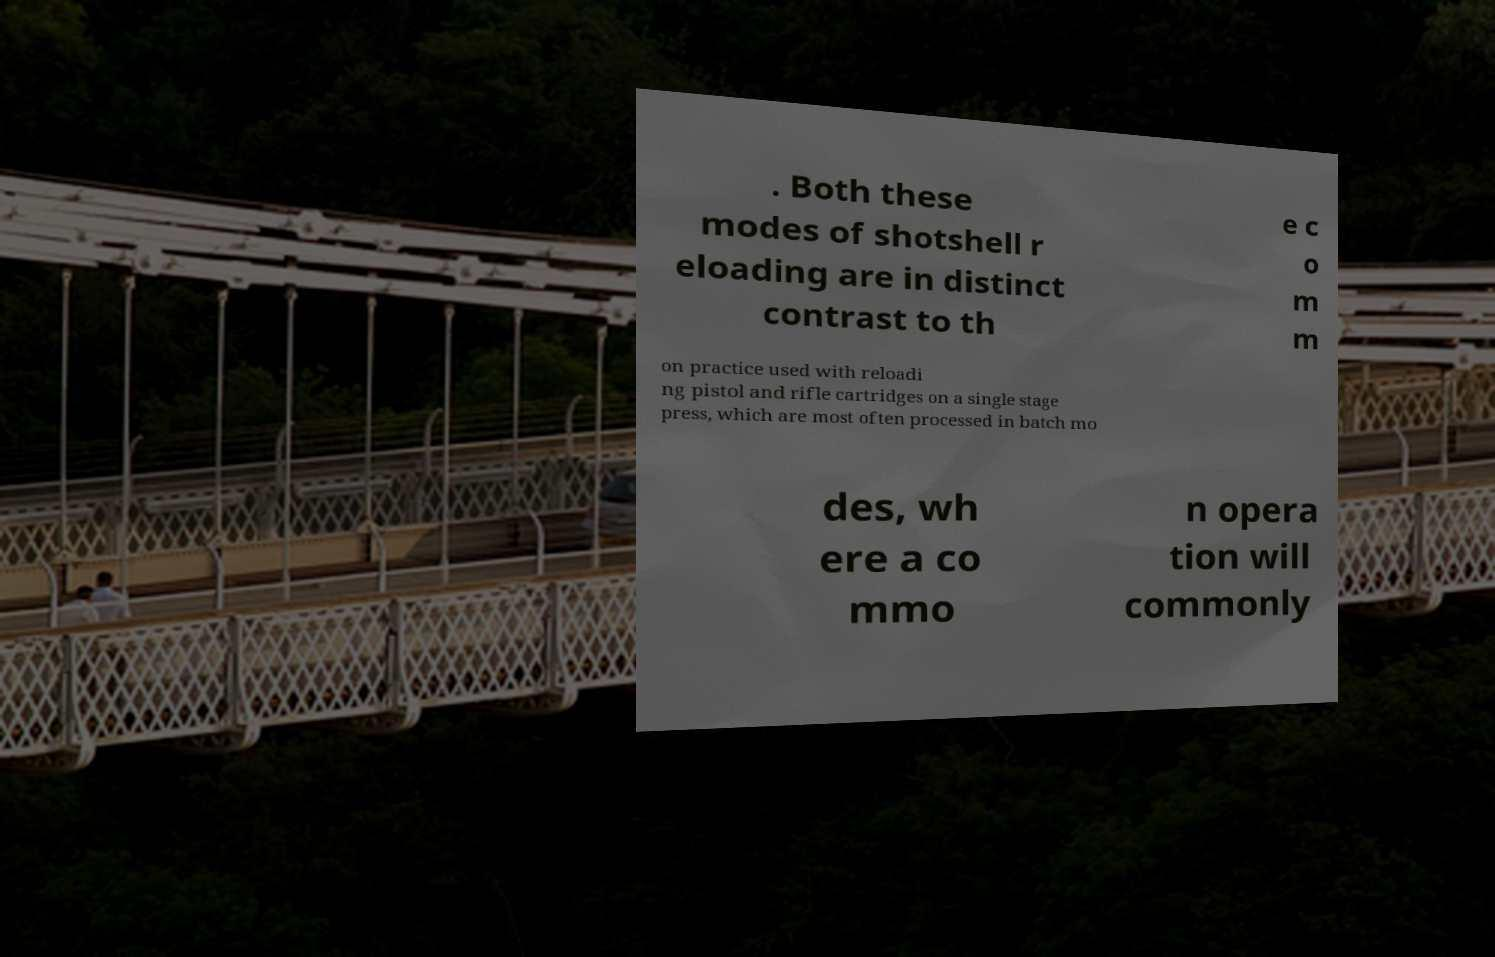For documentation purposes, I need the text within this image transcribed. Could you provide that? . Both these modes of shotshell r eloading are in distinct contrast to th e c o m m on practice used with reloadi ng pistol and rifle cartridges on a single stage press, which are most often processed in batch mo des, wh ere a co mmo n opera tion will commonly 